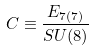Convert formula to latex. <formula><loc_0><loc_0><loc_500><loc_500>C \equiv \frac { E _ { 7 ( 7 ) } } { S U ( 8 ) }</formula> 